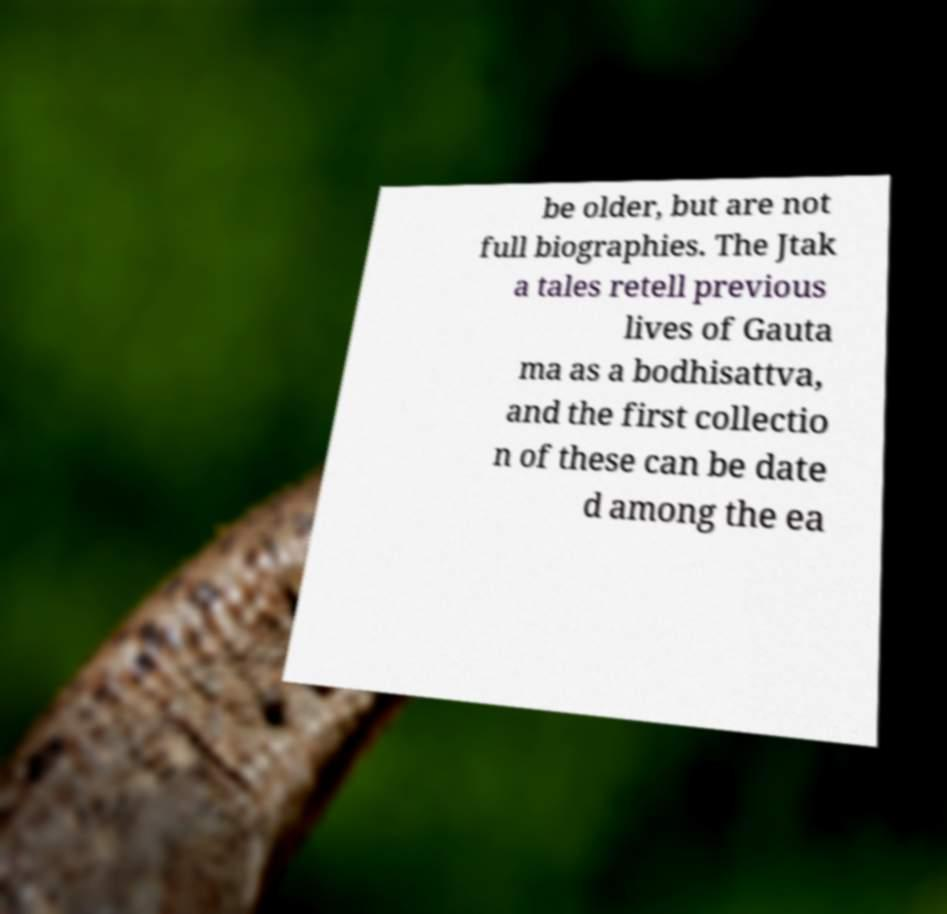I need the written content from this picture converted into text. Can you do that? be older, but are not full biographies. The Jtak a tales retell previous lives of Gauta ma as a bodhisattva, and the first collectio n of these can be date d among the ea 